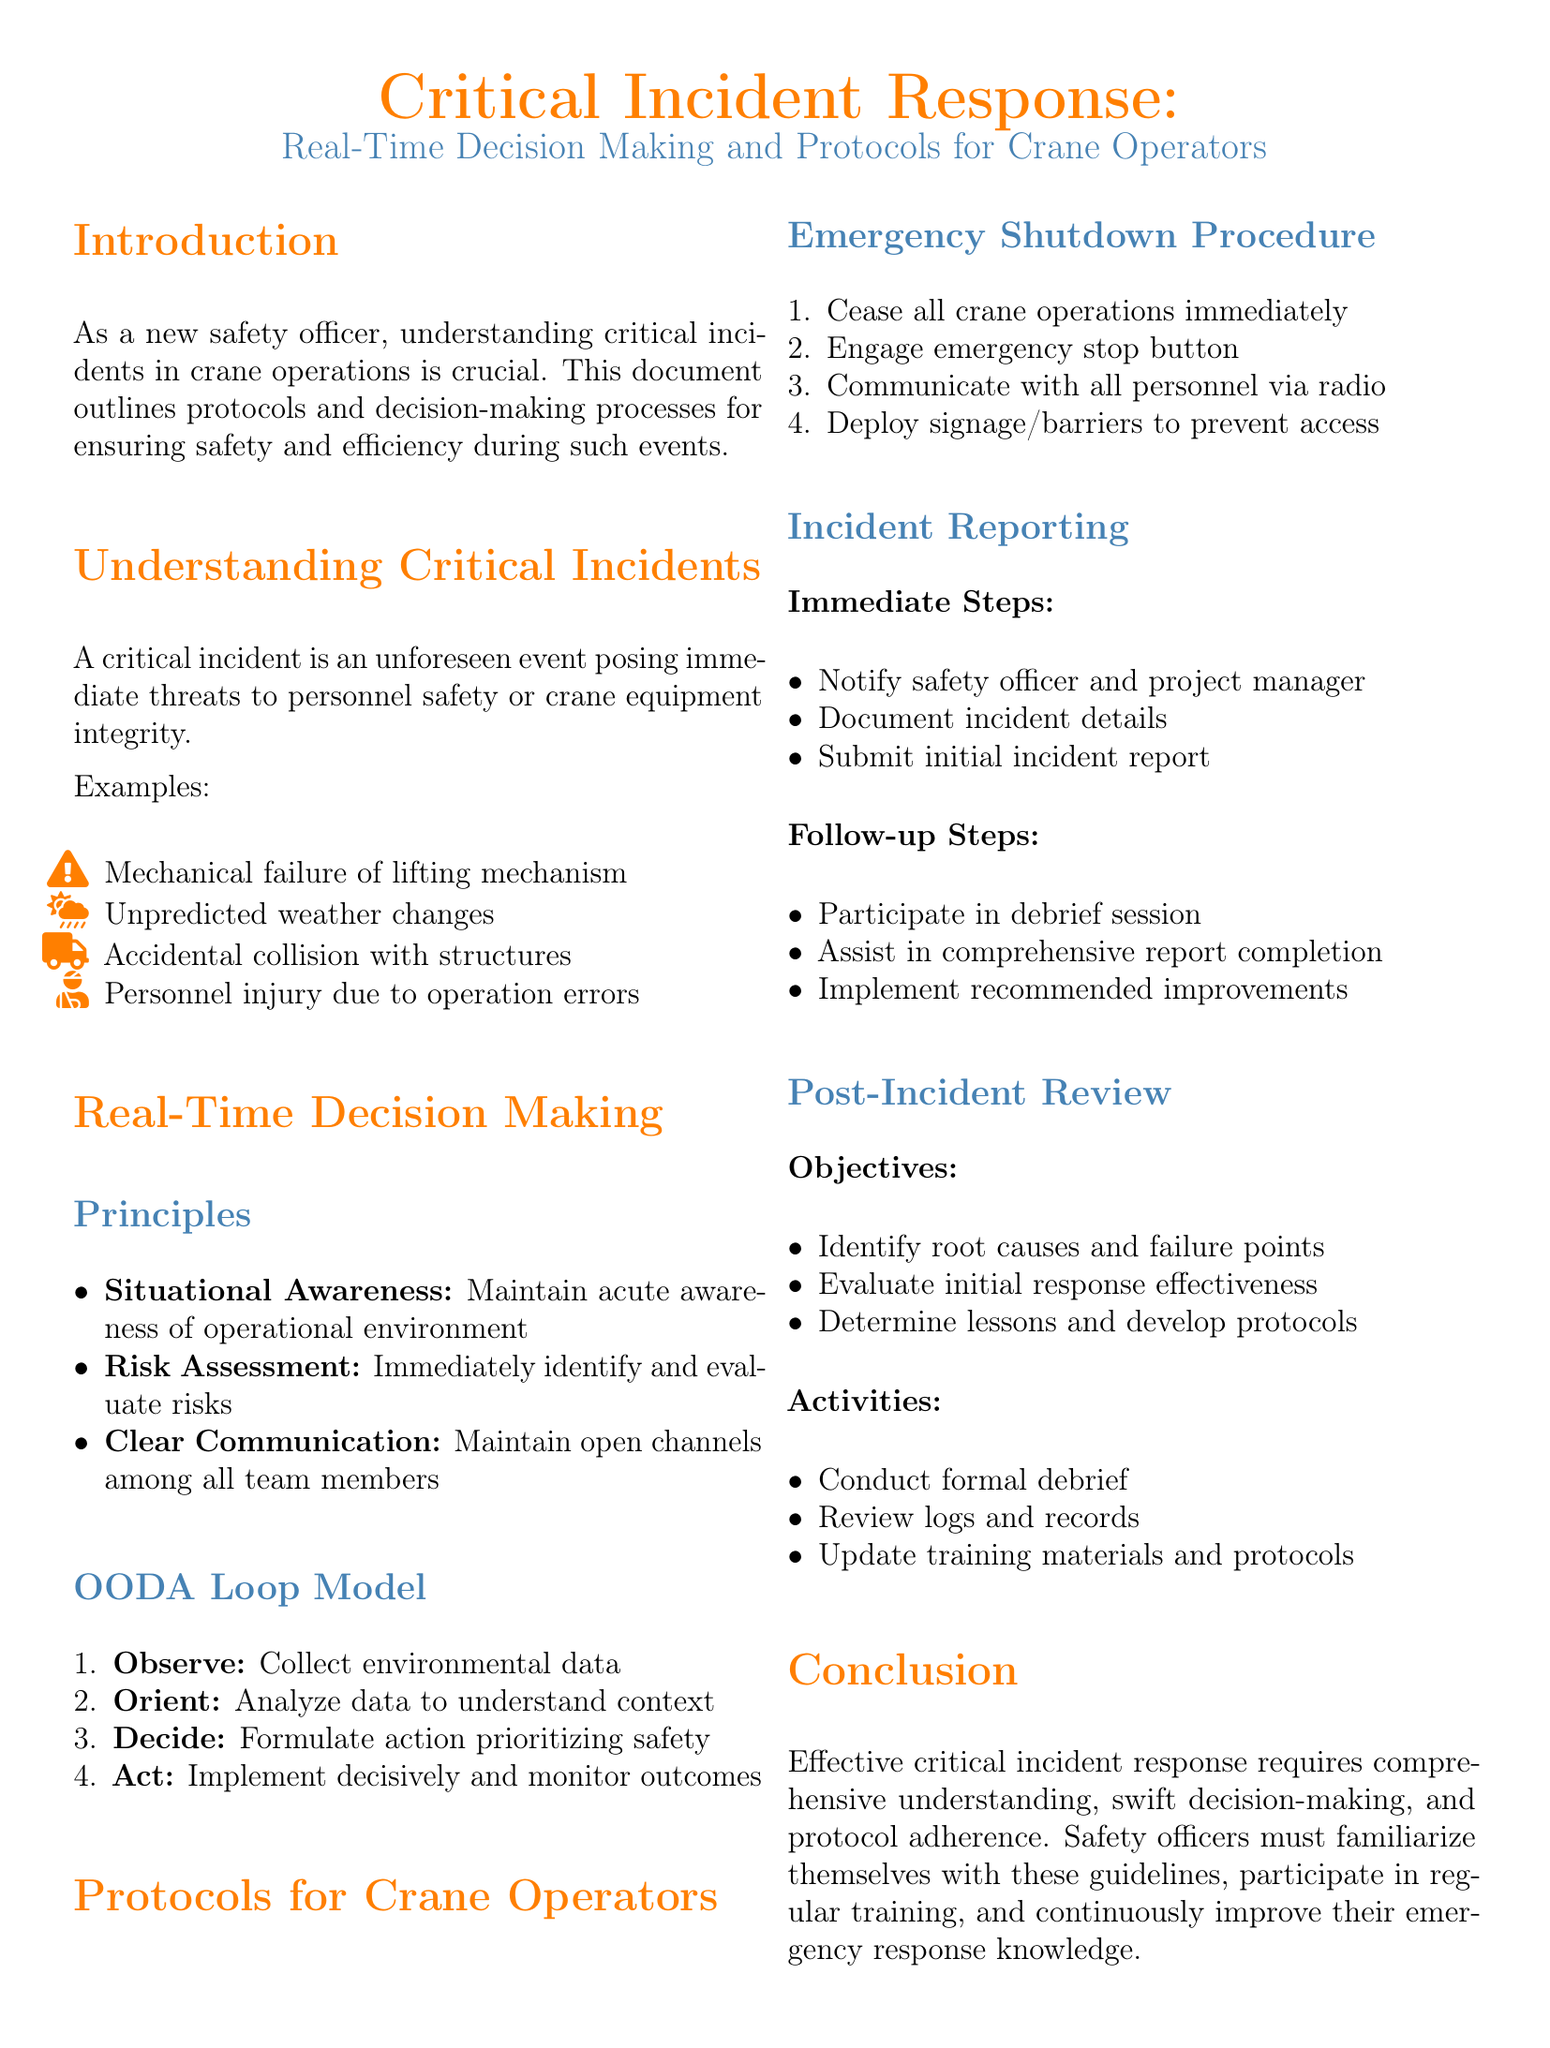What is a critical incident? A critical incident is an unforeseen event posing immediate threats to personnel safety or crane equipment integrity.
Answer: Unforeseen event What are the three immediate steps in incident reporting? The immediate steps in incident reporting include notifying the safety officer, documenting incident details, and submitting the initial incident report.
Answer: Notify, document, submit What does the OODA Loop stand for? The OODA Loop consists of four stages: Observe, Orient, Decide, and Act.
Answer: Observe, Orient, Decide, Act What is the first step in the emergency shutdown procedure? The first step in the emergency shutdown procedure is to cease all crane operations immediately.
Answer: Cease all operations What is the objective of the post-incident review? The objective of the post-incident review is to identify root causes and failure points.
Answer: Identify root causes What principle requires maintaining open channels among team members? The principle that requires maintaining open channels among team members is Clear Communication.
Answer: Clear Communication How many activities are listed for the post-incident review? There are three activities listed for the post-incident review, including conducting a formal debrief.
Answer: Three activities What is essential for effective critical incident response? A comprehensive understanding, swift decision-making, and protocol adherence are essential for effective critical incident response.
Answer: Comprehensive understanding What should safety officers regularly participate in? Safety officers should regularly participate in training.
Answer: Regular training 